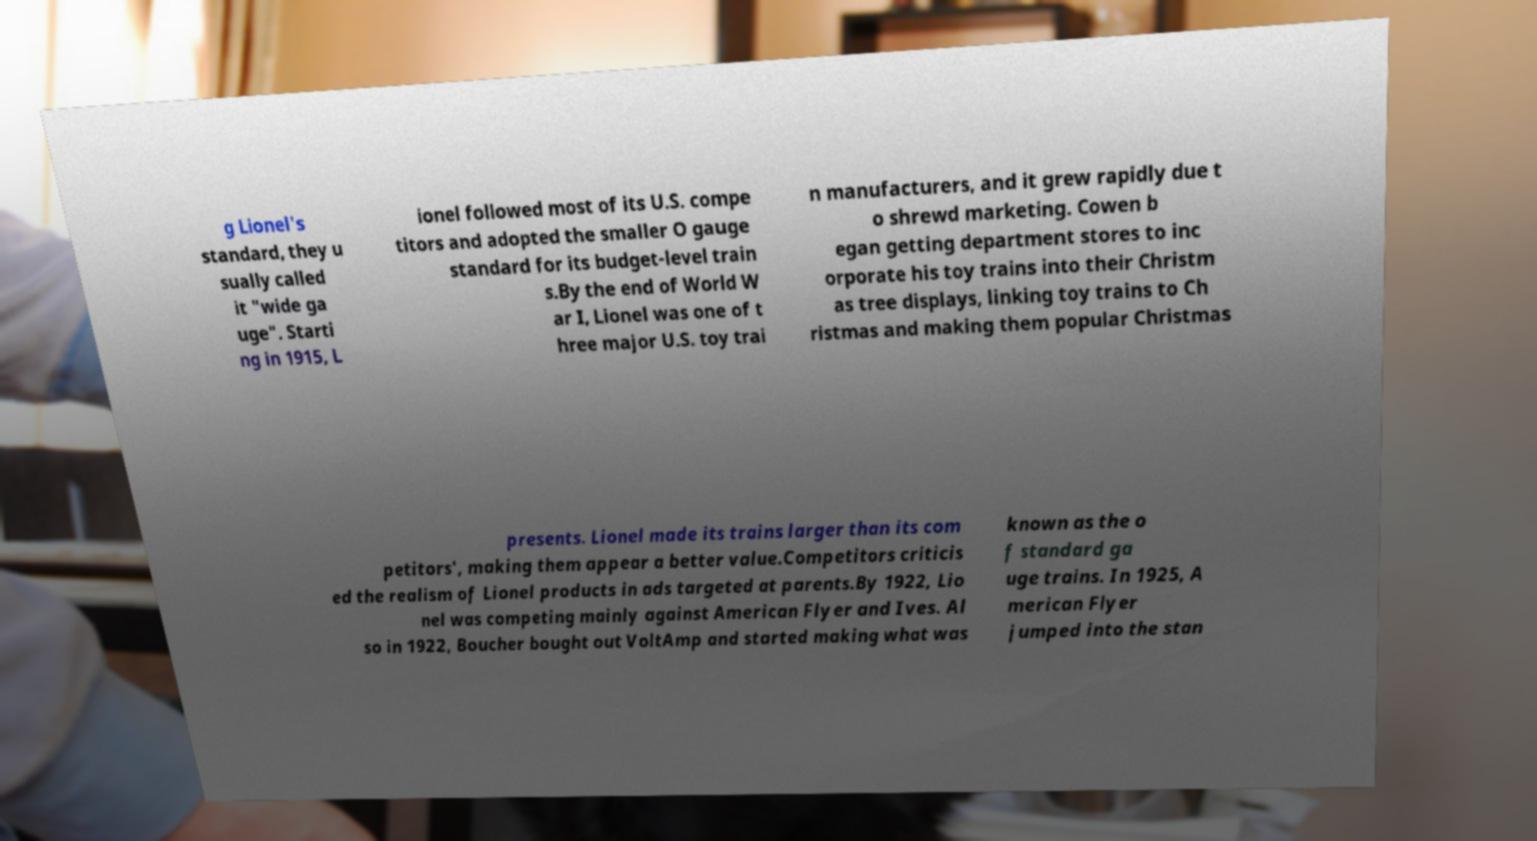Can you read and provide the text displayed in the image?This photo seems to have some interesting text. Can you extract and type it out for me? g Lionel's standard, they u sually called it "wide ga uge". Starti ng in 1915, L ionel followed most of its U.S. compe titors and adopted the smaller O gauge standard for its budget-level train s.By the end of World W ar I, Lionel was one of t hree major U.S. toy trai n manufacturers, and it grew rapidly due t o shrewd marketing. Cowen b egan getting department stores to inc orporate his toy trains into their Christm as tree displays, linking toy trains to Ch ristmas and making them popular Christmas presents. Lionel made its trains larger than its com petitors', making them appear a better value.Competitors criticis ed the realism of Lionel products in ads targeted at parents.By 1922, Lio nel was competing mainly against American Flyer and Ives. Al so in 1922, Boucher bought out VoltAmp and started making what was known as the o f standard ga uge trains. In 1925, A merican Flyer jumped into the stan 